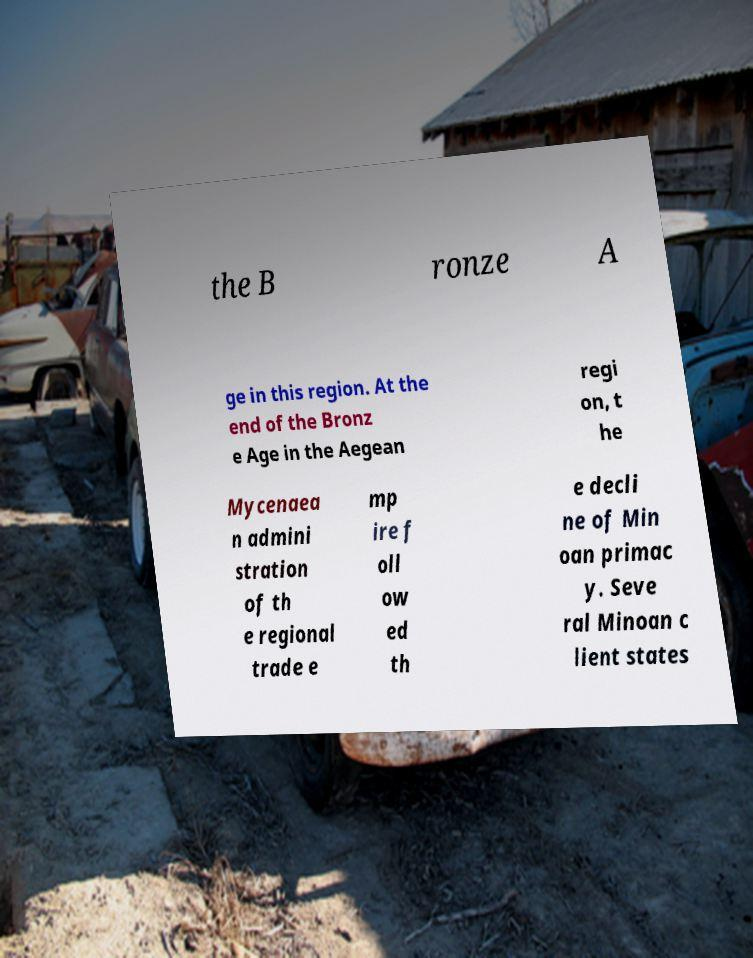Could you assist in decoding the text presented in this image and type it out clearly? the B ronze A ge in this region. At the end of the Bronz e Age in the Aegean regi on, t he Mycenaea n admini stration of th e regional trade e mp ire f oll ow ed th e decli ne of Min oan primac y. Seve ral Minoan c lient states 